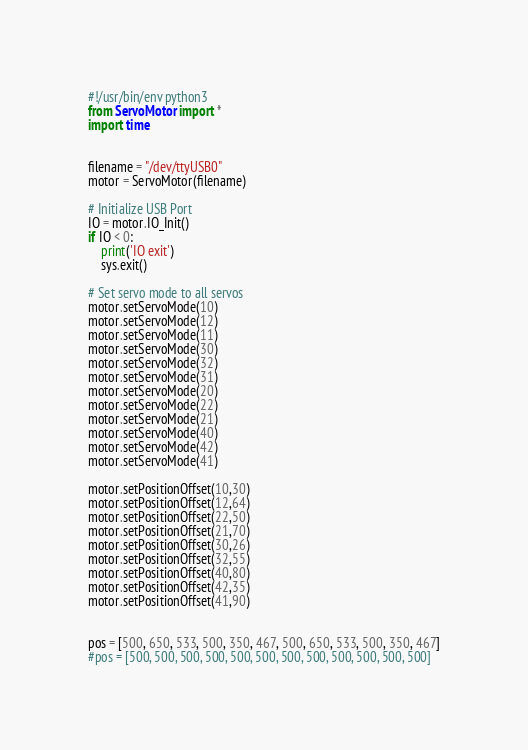<code> <loc_0><loc_0><loc_500><loc_500><_Python_>#!/usr/bin/env python3
from ServoMotor import *
import time


filename = "/dev/ttyUSB0"
motor = ServoMotor(filename)

# Initialize USB Port
IO = motor.IO_Init()
if IO < 0:
    print('IO exit')
    sys.exit()

# Set servo mode to all servos
motor.setServoMode(10)
motor.setServoMode(12)
motor.setServoMode(11)
motor.setServoMode(30)
motor.setServoMode(32)
motor.setServoMode(31)
motor.setServoMode(20)
motor.setServoMode(22)
motor.setServoMode(21)
motor.setServoMode(40)
motor.setServoMode(42)
motor.setServoMode(41)

motor.setPositionOffset(10,30)
motor.setPositionOffset(12,64)
motor.setPositionOffset(22,50)
motor.setPositionOffset(21,70)
motor.setPositionOffset(30,26)
motor.setPositionOffset(32,55)
motor.setPositionOffset(40,80)
motor.setPositionOffset(42,35)
motor.setPositionOffset(41,90)


pos = [500, 650, 533, 500, 350, 467, 500, 650, 533, 500, 350, 467]
#pos = [500, 500, 500, 500, 500, 500, 500, 500, 500, 500, 500, 500]
</code> 